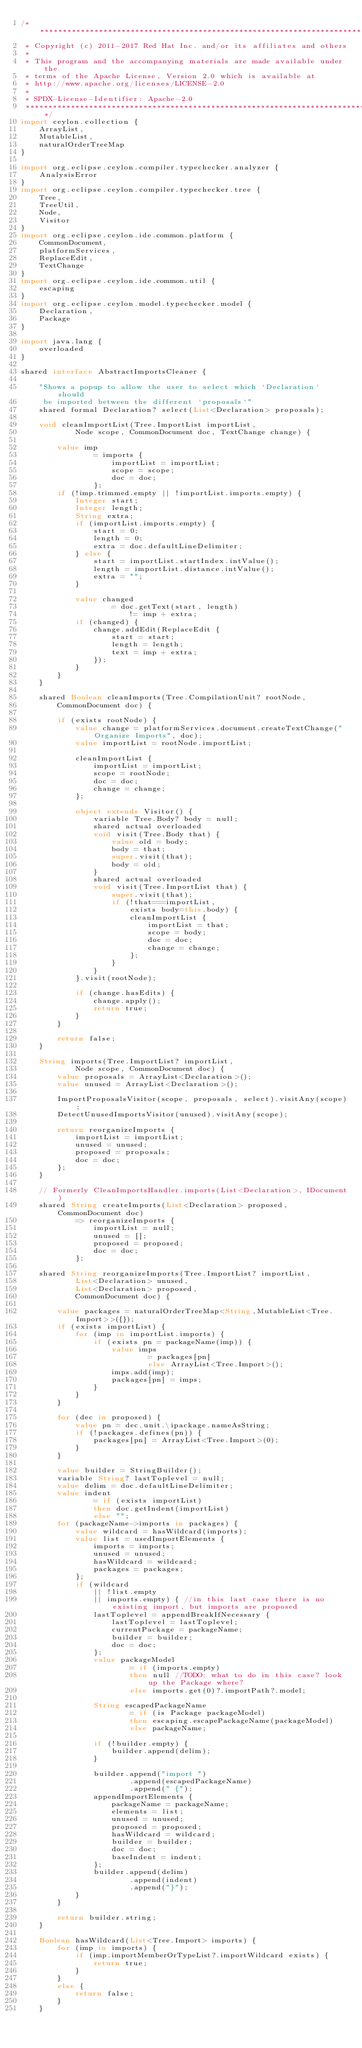Convert code to text. <code><loc_0><loc_0><loc_500><loc_500><_Ceylon_>/********************************************************************************
 * Copyright (c) 2011-2017 Red Hat Inc. and/or its affiliates and others
 *
 * This program and the accompanying materials are made available under the 
 * terms of the Apache License, Version 2.0 which is available at
 * http://www.apache.org/licenses/LICENSE-2.0
 *
 * SPDX-License-Identifier: Apache-2.0 
 ********************************************************************************/
import ceylon.collection {
    ArrayList,
    MutableList,
    naturalOrderTreeMap
}

import org.eclipse.ceylon.compiler.typechecker.analyzer {
    AnalysisError
}
import org.eclipse.ceylon.compiler.typechecker.tree {
    Tree,
    TreeUtil,
    Node,
    Visitor
}
import org.eclipse.ceylon.ide.common.platform {
    CommonDocument,
    platformServices,
    ReplaceEdit,
    TextChange
}
import org.eclipse.ceylon.ide.common.util {
    escaping
}
import org.eclipse.ceylon.model.typechecker.model {
    Declaration,
    Package
}

import java.lang {
    overloaded
}

shared interface AbstractImportsCleaner {
    
    "Shows a popup to allow the user to select which `Declaration` should
     be imported between the different `proposals`"
    shared formal Declaration? select(List<Declaration> proposals);
    
    void cleanImportList(Tree.ImportList importList,
            Node scope, CommonDocument doc, TextChange change) {

        value imp
                = imports {
                    importList = importList;
                    scope = scope;
                    doc = doc;
                };
        if (!imp.trimmed.empty || !importList.imports.empty) {
            Integer start;
            Integer length;
            String extra;
            if (importList.imports.empty) {
                start = 0;
                length = 0;
                extra = doc.defaultLineDelimiter;
            } else {
                start = importList.startIndex.intValue();
                length = importList.distance.intValue();
                extra = "";
            }

            value changed
                    = doc.getText(start, length)
                        != imp + extra;
            if (changed) {
                change.addEdit(ReplaceEdit {
                    start = start;
                    length = length;
                    text = imp + extra;
                });
            }
        }
    }

    shared Boolean cleanImports(Tree.CompilationUnit? rootNode,
        CommonDocument doc) {

        if (exists rootNode) {
            value change = platformServices.document.createTextChange("Organize Imports", doc);
            value importList = rootNode.importList;

            cleanImportList {
                importList = importList;
                scope = rootNode;
                doc = doc;
                change = change;
            };

            object extends Visitor() {
                variable Tree.Body? body = null;
                shared actual overloaded
                void visit(Tree.Body that) {
                    value old = body;
                    body = that;
                    super.visit(that);
                    body = old;
                }
                shared actual overloaded
                void visit(Tree.ImportList that) {
                    super.visit(that);
                    if (!that===importList,
                        exists body=this.body) {
                        cleanImportList {
                            importList = that;
                            scope = body;
                            doc = doc;
                            change = change;
                        };
                    }
                }
            }.visit(rootNode);

            if (change.hasEdits) {
                change.apply();
                return true;
            }
        }

        return false;
    }
    
    String imports(Tree.ImportList? importList,
            Node scope, CommonDocument doc) {
        value proposals = ArrayList<Declaration>();
        value unused = ArrayList<Declaration>();
        
        ImportProposalsVisitor(scope, proposals, select).visitAny(scope);
        DetectUnusedImportsVisitor(unused).visitAny(scope);
        
        return reorganizeImports {
            importList = importList;
            unused = unused;
            proposed = proposals;
            doc = doc;
        };
    }

    // Formerly CleanImportsHandler.imports(List<Declaration>, IDocument)
    shared String createImports(List<Declaration> proposed, CommonDocument doc)
            => reorganizeImports {
                importList = null;
                unused = [];
                proposed = proposed;
                doc = doc;
            };
    
    shared String reorganizeImports(Tree.ImportList? importList,
            List<Declaration> unused,
            List<Declaration> proposed,
            CommonDocument doc) {
        
        value packages = naturalOrderTreeMap<String,MutableList<Tree.Import>>({});
        if (exists importList) {
            for (imp in importList.imports) {
                if (exists pn = packageName(imp)) {
                    value imps
                            = packages[pn]
                            else ArrayList<Tree.Import>();
                    imps.add(imp);
                    packages[pn] = imps;
                }
            }
        }
        
        for (dec in proposed) {
            value pn = dec.unit.\ipackage.nameAsString;
            if (!packages.defines(pn)) {
                packages[pn] = ArrayList<Tree.Import>(0);
            }
        }
        
        value builder = StringBuilder();
        variable String? lastToplevel = null;
        value delim = doc.defaultLineDelimiter;
        value indent
                = if (exists importList)
                then doc.getIndent(importList)
                else "";
        for (packageName->imports in packages) {
            value wildcard = hasWildcard(imports);
            value list = usedImportElements {
                imports = imports;
                unused = unused;
                hasWildcard = wildcard;
                packages = packages;
            };
            if (wildcard
                || !list.empty
                || imports.empty) { //in this last case there is no existing import, but imports are proposed
                lastToplevel = appendBreakIfNecessary {
                    lastToplevel = lastToplevel;
                    currentPackage = packageName;
                    builder = builder;
                    doc = doc;
                };
                value packageModel
                        = if (imports.empty)
                        then null //TODO: what to do in this case? look up the Package where?
                        else imports.get(0)?.importPath?.model;

                String escapedPackageName
                        = if (is Package packageModel)
                        then escaping.escapePackageName(packageModel)
                        else packageName;
                
                if (!builder.empty) {
                    builder.append(delim);
                }
                
                builder.append("import ")
                        .append(escapedPackageName)
                        .append(" {");
                appendImportElements {
                    packageName = packageName;
                    elements = list;
                    unused = unused;
                    proposed = proposed;
                    hasWildcard = wildcard;
                    builder = builder;
                    doc = doc;
                    baseIndent = indent;
                };
                builder.append(delim)
                        .append(indent)
                        .append("}");
            }
        }
        
        return builder.string;
    }
    
    Boolean hasWildcard(List<Tree.Import> imports) {
        for (imp in imports) {
            if (imp.importMemberOrTypeList?.importWildcard exists) {
                return true;
            }
        }
        else {
            return false;
        }
    }
    </code> 